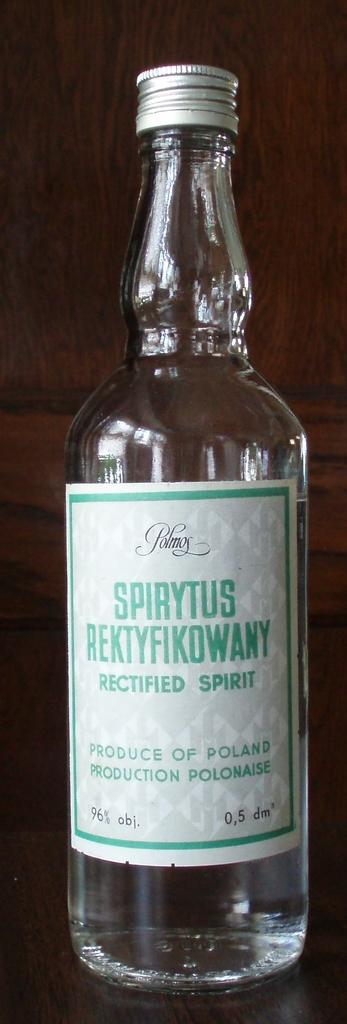What type of container is visible in the image? There is a glass bottle in the image. What is written on the bottle? The bottle has "rectified spirit" written on it. Where is the bottle located in the image? The bottle is placed on a table. What type of plants can be seen in the garden in the image? There is no garden present in the image; it features a glass bottle with "rectified spirit" written on it, placed on a table. What type of material is used to make the chess pieces in the image? There is no chess set present in the image. 